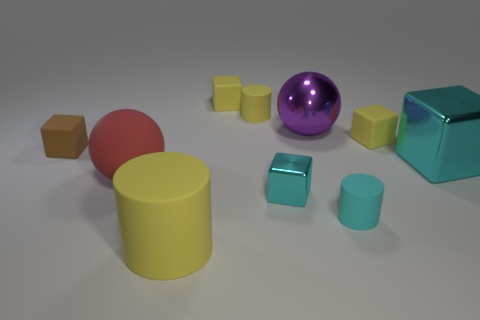Do the purple metallic thing and the brown rubber thing have the same size? Upon closer examination, the purple metallic sphere and the brown rubber cube do not share the same dimensions. The sphere has a diameter that suggests it's larger than the edge length of the cube, making the sphere's volume greater as well. 